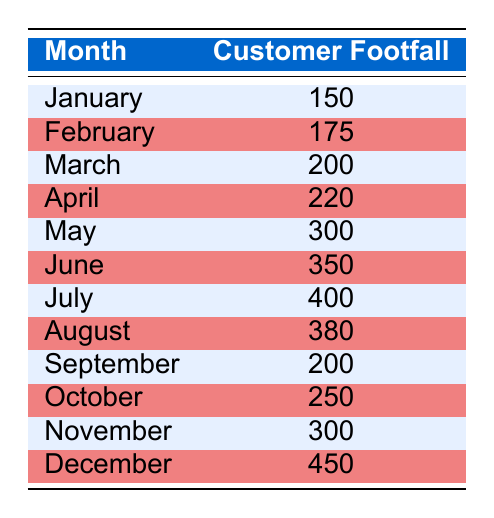What was the customer footfall in December? From the table, the value corresponding to December is given directly, which shows a customer footfall of 450.
Answer: 450 Which month had the highest customer footfall? By comparing all the values in the table, December has the maximum footfall of 450, while all other months have lower values.
Answer: December What is the average customer footfall from June to August? First, we sum the customer footfall for June (350), July (400), and August (380), which equals 1130. Then, we divide this sum by the number of months (3): 1130 / 3 = 376.67.
Answer: 376.67 Did more customers visit in November compared to January? The customer footfall for November is 300 and for January is 150. Since 300 is greater than 150, it confirms that November had a higher footfall.
Answer: Yes How much more footfall was there in July than in September? The value for July is 400 and for September is 200. The difference is calculated by subtracting September's footfall from July's: 400 - 200 = 200.
Answer: 200 Which month saw a footfall of 220 customers? The month with a footfall of 220 customers can be directly observed from the table, and that month is April.
Answer: April What is the total customer footfall for the first half of the year (January to June)? To get the total, we add the monthly footfalls from January (150), February (175), March (200), April (220), May (300), and June (350). The sum is 1395.
Answer: 1395 Was the customer footfall in May greater than April? In the table, May has a footfall of 300 and April has 220. Since 300 is greater than 220, the statement is true.
Answer: Yes What is the customer footfall trend from January to July? Examining the values in the table, we find that customer footfall consistently increases from January (150) to July (400). This shows a clear upward trend over these months.
Answer: Increasing 